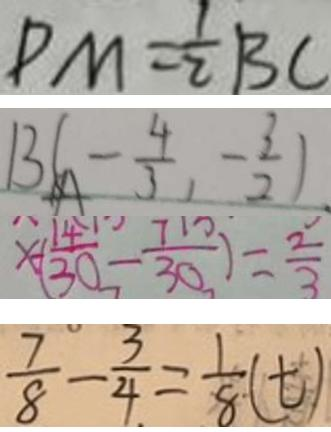Convert formula to latex. <formula><loc_0><loc_0><loc_500><loc_500>P M = \frac { 1 } { 2 } B C 
 B ( - \frac { 4 } { 3 } , - \frac { 3 } { 2 } ) . 
 x - ( \frac { 1 4 } { 3 0 } - \frac { 7 } { 3 0 } ) = \frac { 2 } { 3 } 
 \frac { 7 } { 8 } - \frac { 3 } { 4 } = \frac { 1 } { 8 } ( t )</formula> 